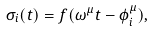Convert formula to latex. <formula><loc_0><loc_0><loc_500><loc_500>\sigma _ { i } ( t ) = f ( \omega ^ { \mu } t - \phi ^ { \mu } _ { i } ) ,</formula> 